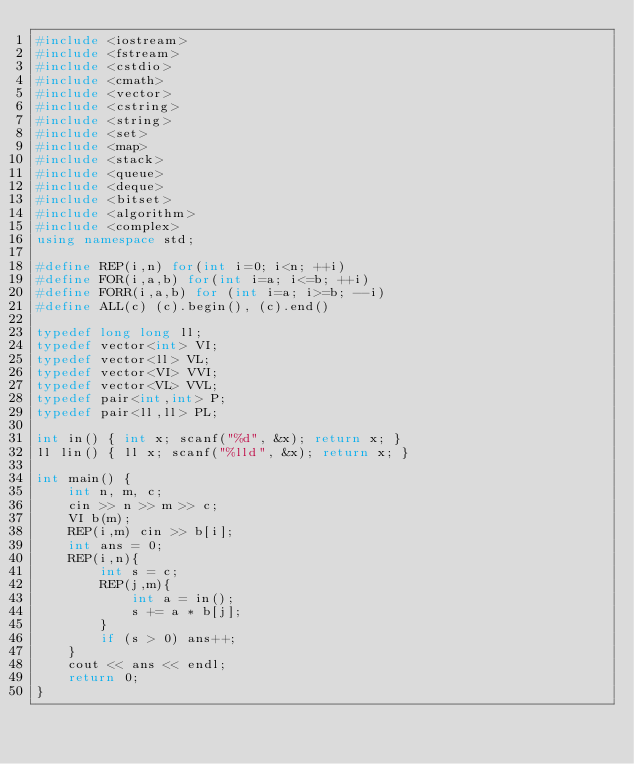<code> <loc_0><loc_0><loc_500><loc_500><_C++_>#include <iostream>
#include <fstream>
#include <cstdio>
#include <cmath>
#include <vector>
#include <cstring>
#include <string>
#include <set>
#include <map>
#include <stack>
#include <queue>
#include <deque>
#include <bitset>
#include <algorithm>
#include <complex>
using namespace std;
 
#define REP(i,n) for(int i=0; i<n; ++i)
#define FOR(i,a,b) for(int i=a; i<=b; ++i)
#define FORR(i,a,b) for (int i=a; i>=b; --i)
#define ALL(c) (c).begin(), (c).end()
 
typedef long long ll;
typedef vector<int> VI;
typedef vector<ll> VL;
typedef vector<VI> VVI;
typedef vector<VL> VVL;
typedef pair<int,int> P;
typedef pair<ll,ll> PL;

int in() { int x; scanf("%d", &x); return x; }
ll lin() { ll x; scanf("%lld", &x); return x; }

int main() {
    int n, m, c;
    cin >> n >> m >> c;
    VI b(m);
    REP(i,m) cin >> b[i];
    int ans = 0;
    REP(i,n){
        int s = c;
        REP(j,m){
            int a = in();
            s += a * b[j];
        }
        if (s > 0) ans++;
    }
    cout << ans << endl;
    return 0;
}</code> 